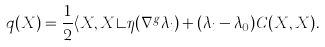Convert formula to latex. <formula><loc_0><loc_0><loc_500><loc_500>q ( X ) = \frac { 1 } { 2 } \langle X , X \rangle \eta ( \nabla ^ { g } \lambda _ { i } ) + ( \lambda _ { i } - \lambda _ { 0 } ) C ( X , X ) .</formula> 